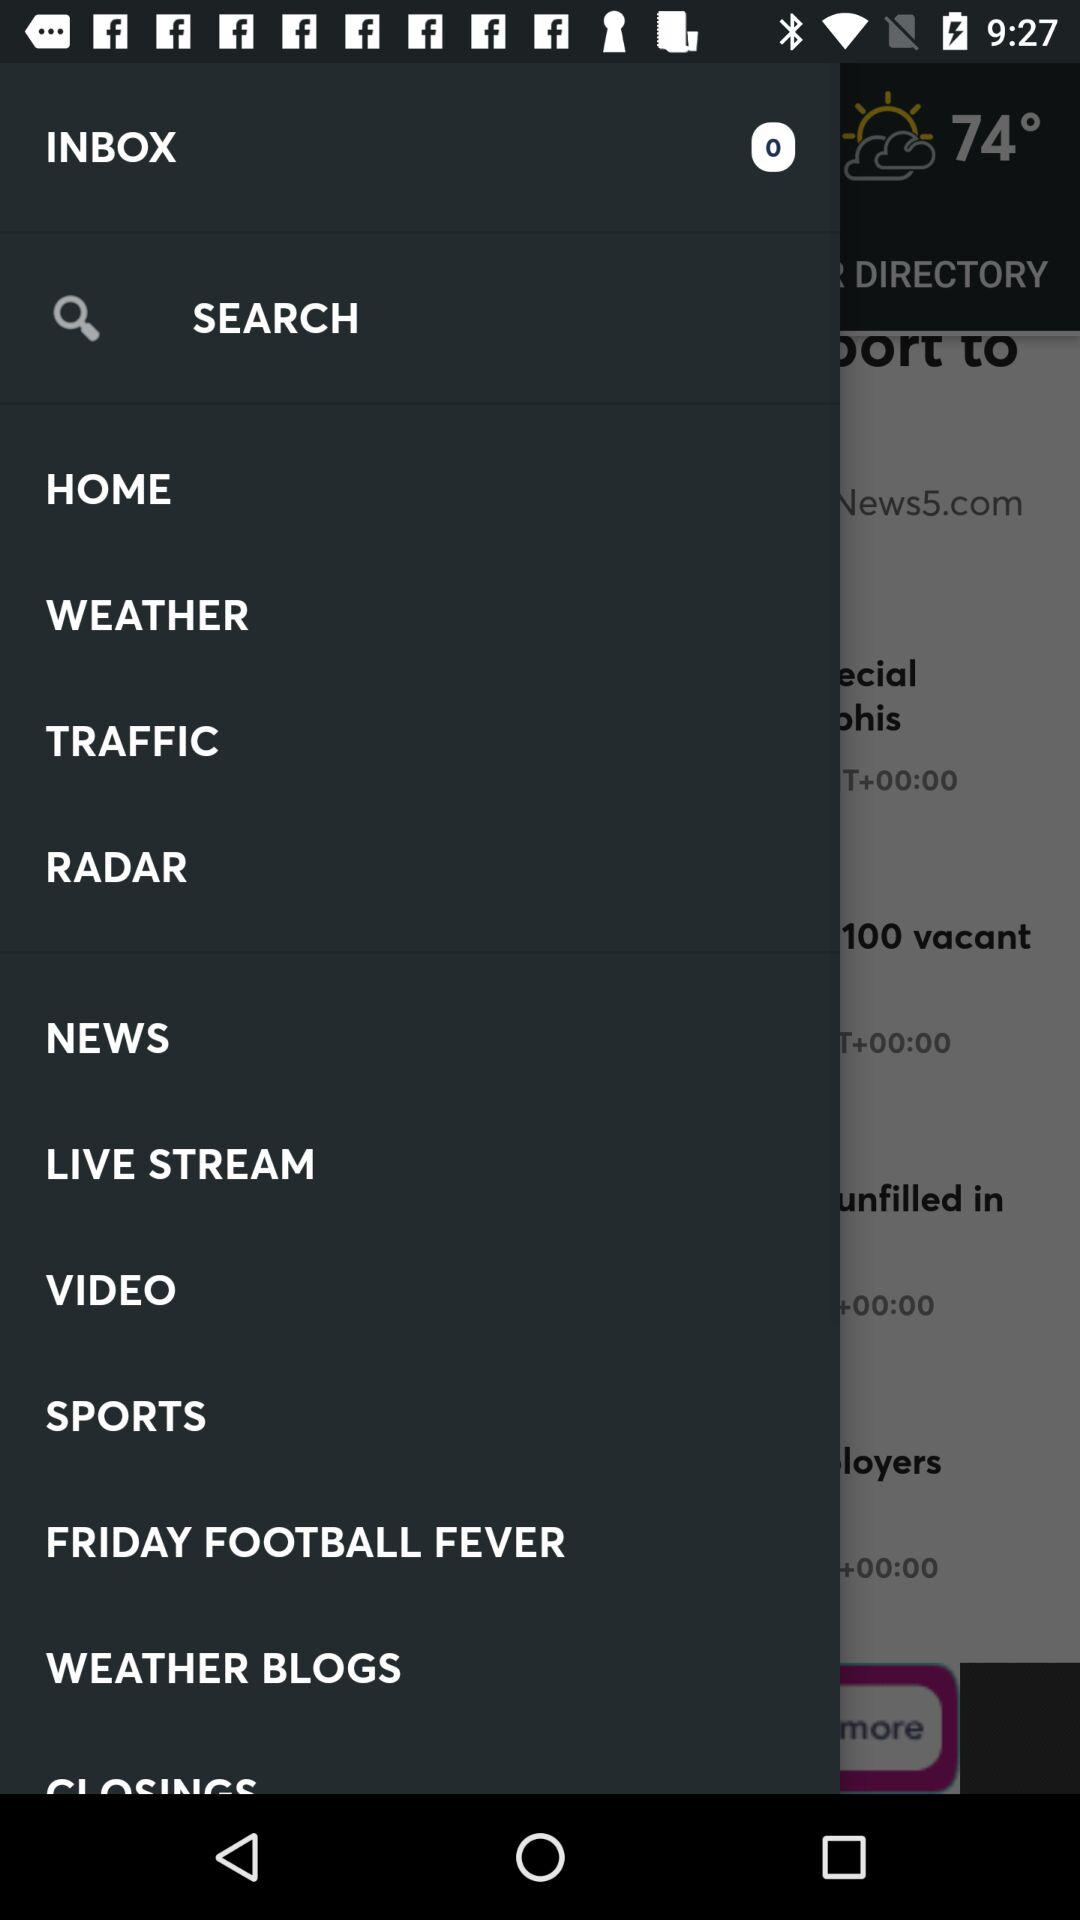What type of weather is shown on the screen? The weather is partly cloudy. 